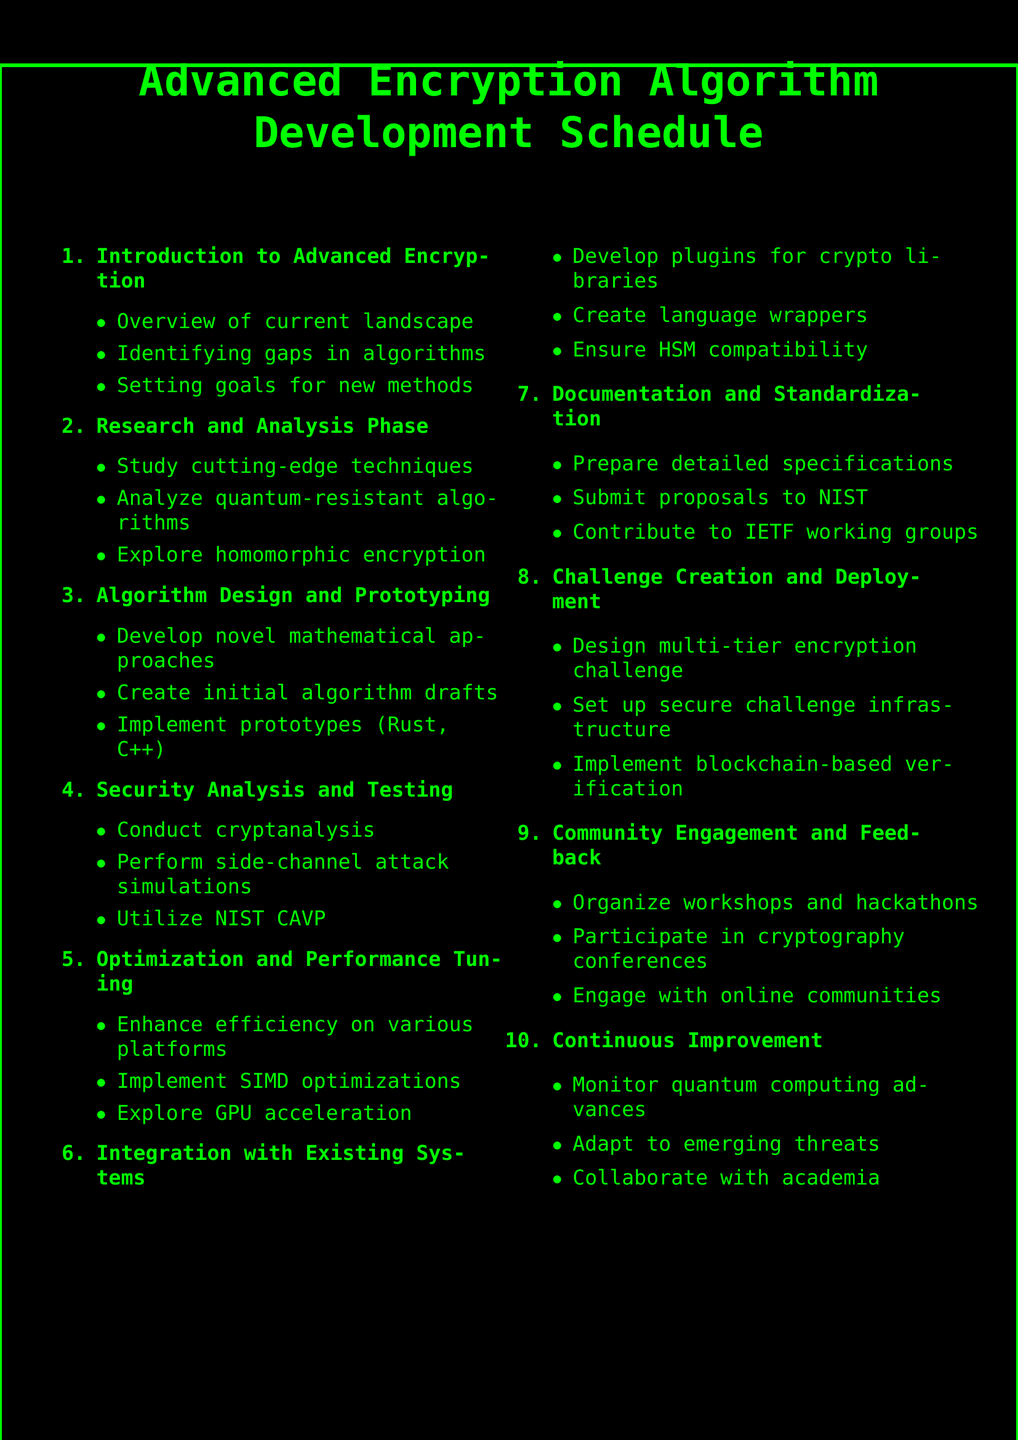What is the first item in the agenda? The first item in the agenda is "Introduction to Advanced Encryption Algorithm Development".
Answer: Introduction to Advanced Encryption Algorithm Development How many phases are listed in the agenda? There are ten main agenda items listed in the document.
Answer: Ten What programming languages are mentioned for implementing prototypes? The programming languages mentioned for implementing prototypes are Rust and C++.
Answer: Rust and C++ Which cryptographic technique is analyzed in the research phase? The document states that "quantum-resistant algorithms" are analyzed in the research phase.
Answer: Quantum-resistant algorithms What is the focus of the "Optimization and Performance Tuning" item? The focus is on enhancing algorithm efficiency on various hardware platforms and exploring GPU acceleration.
Answer: Enhancing algorithm efficiency What does CAVP stand for as mentioned in the document? CAVP stands for Cryptographic Algorithm Validation Program as stated in the "Security Analysis and Testing" section.
Answer: Cryptographic Algorithm Validation Program What kind of challenge is being created according to the agenda? A "multi-tier encryption challenge" is being created.
Answer: Multi-tier encryption challenge Which external organization is mentioned for proposal submission? The proposals are to be submitted to NIST for evaluation.
Answer: NIST In which phase is "homomorphic encryption" explored? "Homomorphic encryption" is explored in the "Research and Analysis Phase".
Answer: Research and Analysis Phase What community activities are included in the engagement section? The agenda includes organizing "cryptography workshops and hackathons".
Answer: cryptography workshops and hackathons 